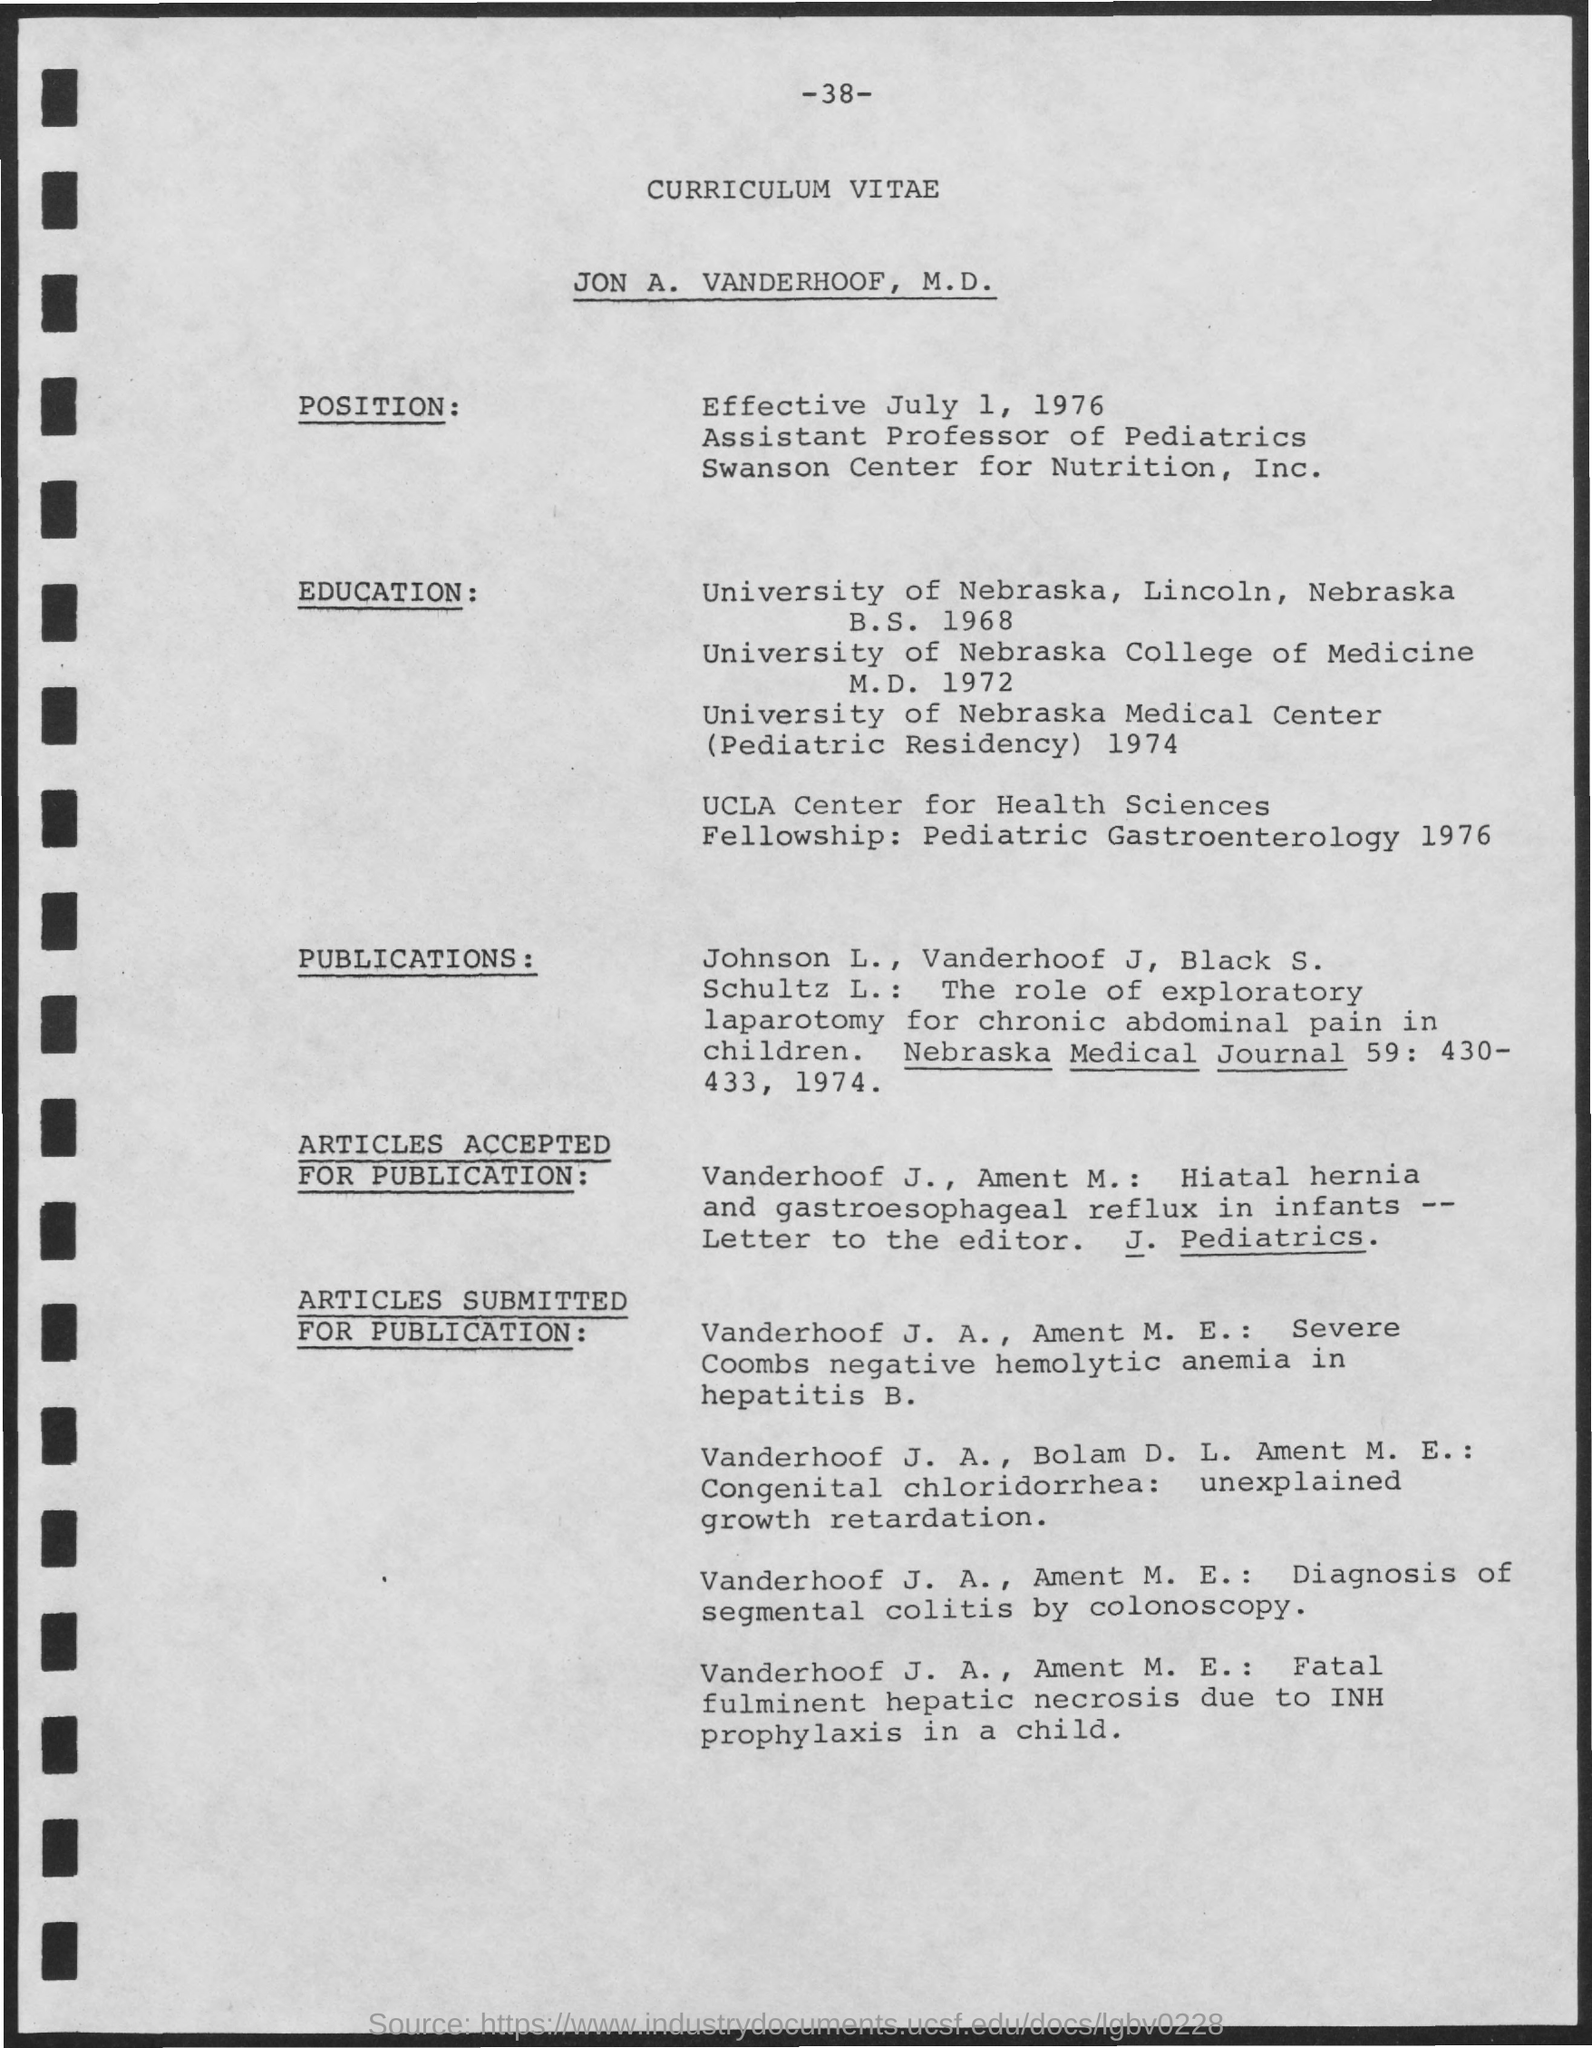Indicate a few pertinent items in this graphic. The position became effective on July 1, 1976. Jon is currently an Assistant Professor of Pediatrics. This is a curriculum vitae. The curriculum vitae belongs to Jon A. Vanderhoof, M.D. Jon's paper has been published in the Nebraska Medical Journal. 